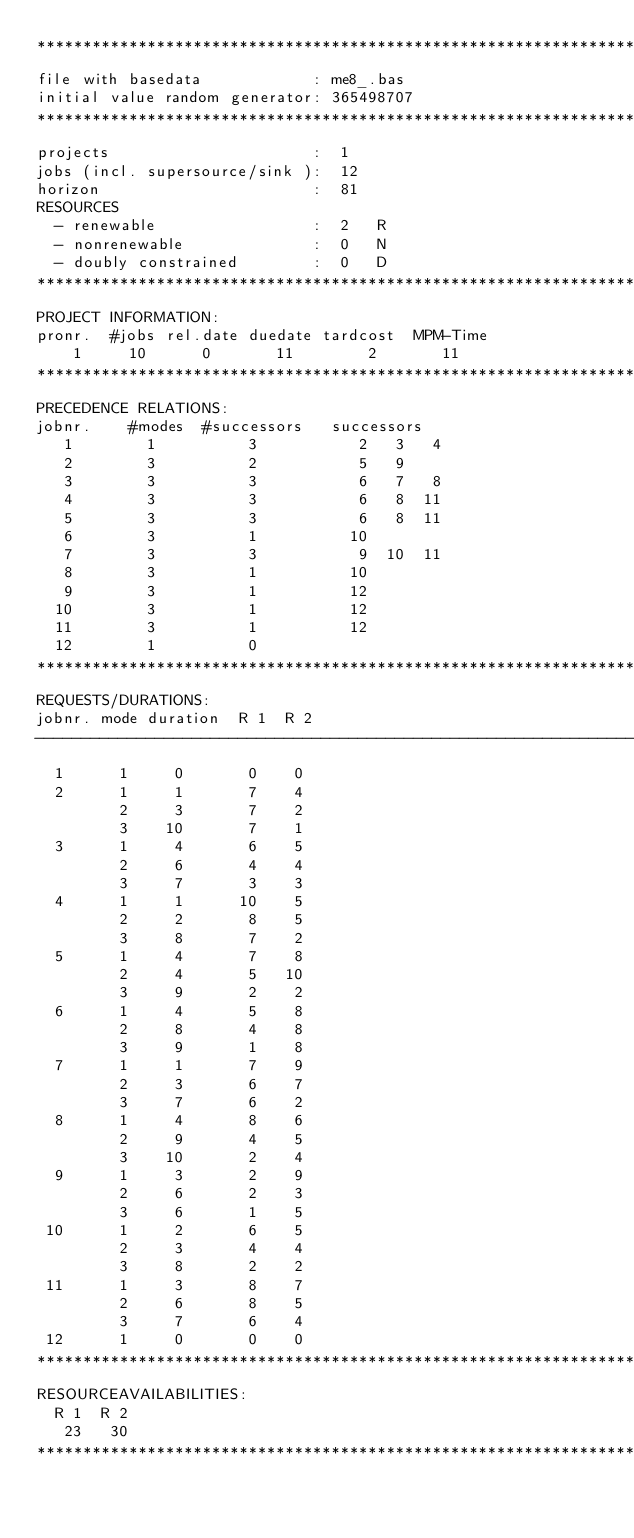Convert code to text. <code><loc_0><loc_0><loc_500><loc_500><_ObjectiveC_>************************************************************************
file with basedata            : me8_.bas
initial value random generator: 365498707
************************************************************************
projects                      :  1
jobs (incl. supersource/sink ):  12
horizon                       :  81
RESOURCES
  - renewable                 :  2   R
  - nonrenewable              :  0   N
  - doubly constrained        :  0   D
************************************************************************
PROJECT INFORMATION:
pronr.  #jobs rel.date duedate tardcost  MPM-Time
    1     10      0       11        2       11
************************************************************************
PRECEDENCE RELATIONS:
jobnr.    #modes  #successors   successors
   1        1          3           2   3   4
   2        3          2           5   9
   3        3          3           6   7   8
   4        3          3           6   8  11
   5        3          3           6   8  11
   6        3          1          10
   7        3          3           9  10  11
   8        3          1          10
   9        3          1          12
  10        3          1          12
  11        3          1          12
  12        1          0        
************************************************************************
REQUESTS/DURATIONS:
jobnr. mode duration  R 1  R 2
------------------------------------------------------------------------
  1      1     0       0    0
  2      1     1       7    4
         2     3       7    2
         3    10       7    1
  3      1     4       6    5
         2     6       4    4
         3     7       3    3
  4      1     1      10    5
         2     2       8    5
         3     8       7    2
  5      1     4       7    8
         2     4       5   10
         3     9       2    2
  6      1     4       5    8
         2     8       4    8
         3     9       1    8
  7      1     1       7    9
         2     3       6    7
         3     7       6    2
  8      1     4       8    6
         2     9       4    5
         3    10       2    4
  9      1     3       2    9
         2     6       2    3
         3     6       1    5
 10      1     2       6    5
         2     3       4    4
         3     8       2    2
 11      1     3       8    7
         2     6       8    5
         3     7       6    4
 12      1     0       0    0
************************************************************************
RESOURCEAVAILABILITIES:
  R 1  R 2
   23   30
************************************************************************
</code> 